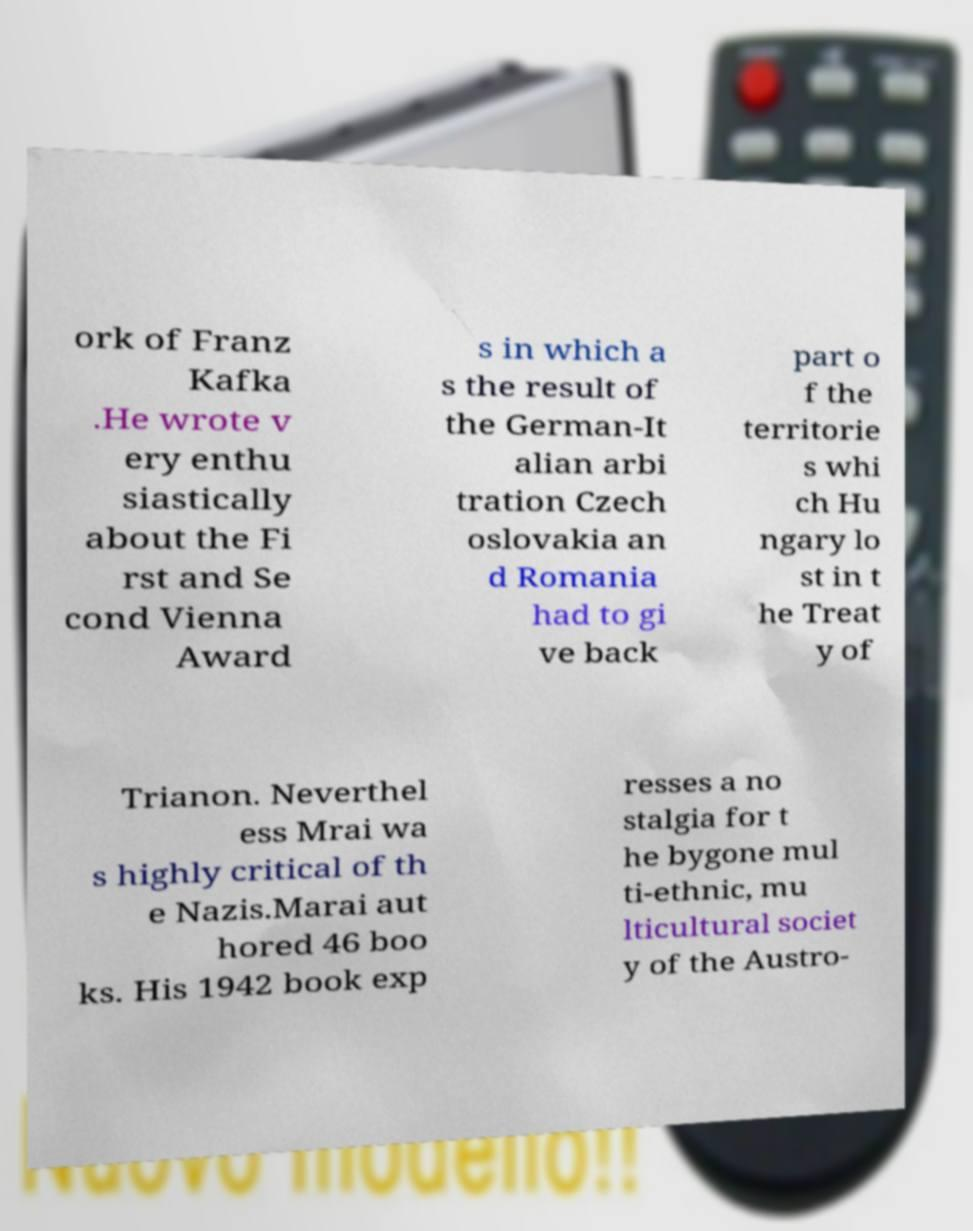Please identify and transcribe the text found in this image. ork of Franz Kafka .He wrote v ery enthu siastically about the Fi rst and Se cond Vienna Award s in which a s the result of the German-It alian arbi tration Czech oslovakia an d Romania had to gi ve back part o f the territorie s whi ch Hu ngary lo st in t he Treat y of Trianon. Neverthel ess Mrai wa s highly critical of th e Nazis.Marai aut hored 46 boo ks. His 1942 book exp resses a no stalgia for t he bygone mul ti-ethnic, mu lticultural societ y of the Austro- 